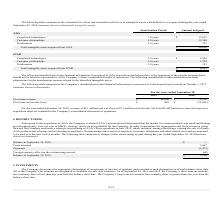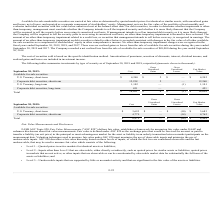According to Mitek Systems's financial document, How long are the maturity dates of the Company’s short-term investments as of September 2018? less than one year from the balance sheet date. The document states: "y’s short-term investments have maturity dates of less than one year from the balance sheet date. The Company’s long-term investments have maturity da..." Also, How does the management review the fair value of the portfolio?  at least monthly and evaluates individual securities with fair value below amortized cost at the balance sheet date. The document states: "anagement reviews the fair value of the portfolio at least monthly and evaluates individual securities with fair value below amortized cost at the bal..." Also, What are the costs of short-term and long-term U.S. Treasury securities, respectively? The document shows two values: $4,240 and 1,102 (in thousands). From the document: "U.S. Treasury, long-term 1,102 — (1) 1,101 U.S. Treasury, short-term $ 4,240 $ 2 $ — $ 4,242..." Additionally, Which securities have the highest fair market value in 2019? Corporate debt securities, short-term. The document states: "Corporate debt securities, short-term 12,258 2 — 12,260..." Also, can you calculate: What is the percentage gain of short-term U.S. Treasury securities in 2019? Based on the calculation: 2/4,242 , the result is 0.05 (percentage). This is based on the information: "U.S. Treasury, short-term $ 4,240 $ 2 $ — $ 4,242 U.S. Treasury, short-term $ 4,240 $ 2 $ — $ 4,242..." The key data points involved are: 2, 4,242. Also, can you calculate: What is the ratio (including both short-term and long-term) of the cost from the U.S. Treasury securities to corporate debt securities in 2019? To answer this question, I need to perform calculations using the financial data. The calculation is: (4,240+1,102)/(12,258+451) , which equals 0.42. This is based on the information: "U.S. Treasury, long-term 1,102 — (1) 1,101 Corporate debt securities, long-term 451 — — 451 Corporate debt securities, short-term 12,258 2 — 12,260 U.S. Treasury, short-term $ 4,240 $ 2 $ — $ 4,242..." The key data points involved are: 1,102, 12,258, 4,240. 